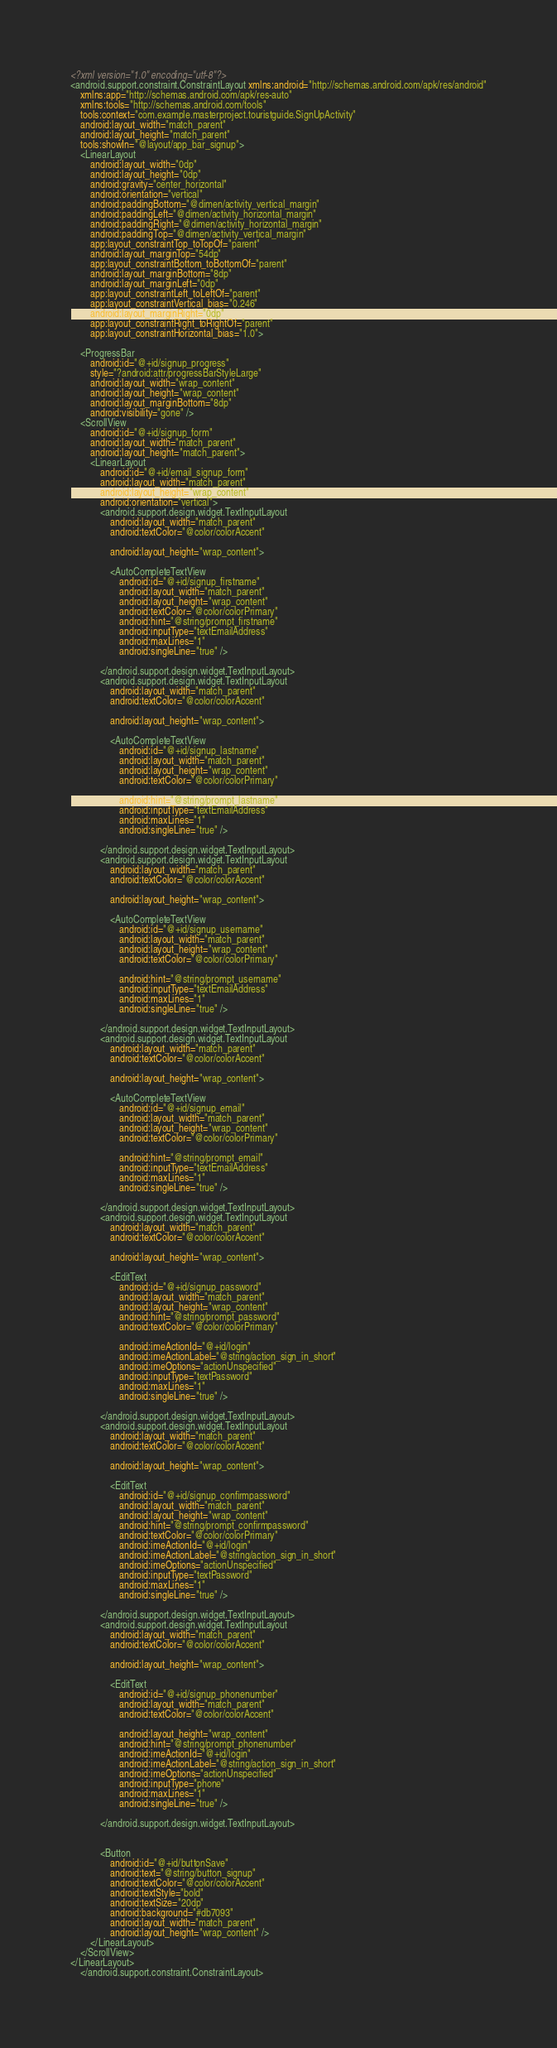<code> <loc_0><loc_0><loc_500><loc_500><_XML_><?xml version="1.0" encoding="utf-8"?>
<android.support.constraint.ConstraintLayout xmlns:android="http://schemas.android.com/apk/res/android"
    xmlns:app="http://schemas.android.com/apk/res-auto"
    xmlns:tools="http://schemas.android.com/tools"
    tools:context="com.example.masterproject.touristguide.SignUpActivity"
    android:layout_width="match_parent"
    android:layout_height="match_parent"
    tools:showIn="@layout/app_bar_signup">
    <LinearLayout
        android:layout_width="0dp"
        android:layout_height="0dp"
        android:gravity="center_horizontal"
        android:orientation="vertical"
        android:paddingBottom="@dimen/activity_vertical_margin"
        android:paddingLeft="@dimen/activity_horizontal_margin"
        android:paddingRight="@dimen/activity_horizontal_margin"
        android:paddingTop="@dimen/activity_vertical_margin"
        app:layout_constraintTop_toTopOf="parent"
        android:layout_marginTop="54dp"
        app:layout_constraintBottom_toBottomOf="parent"
        android:layout_marginBottom="8dp"
        android:layout_marginLeft="0dp"
        app:layout_constraintLeft_toLeftOf="parent"
        app:layout_constraintVertical_bias="0.246"
        android:layout_marginRight="0dp"
        app:layout_constraintRight_toRightOf="parent"
        app:layout_constraintHorizontal_bias="1.0">

    <ProgressBar
        android:id="@+id/signup_progress"
        style="?android:attr/progressBarStyleLarge"
        android:layout_width="wrap_content"
        android:layout_height="wrap_content"
        android:layout_marginBottom="8dp"
        android:visibility="gone" />
    <ScrollView
        android:id="@+id/signup_form"
        android:layout_width="match_parent"
        android:layout_height="match_parent">
        <LinearLayout
            android:id="@+id/email_signup_form"
            android:layout_width="match_parent"
            android:layout_height="wrap_content"
            android:orientation="vertical">
            <android.support.design.widget.TextInputLayout
                android:layout_width="match_parent"
                android:textColor="@color/colorAccent"

                android:layout_height="wrap_content">

                <AutoCompleteTextView
                    android:id="@+id/signup_firstname"
                    android:layout_width="match_parent"
                    android:layout_height="wrap_content"
                    android:textColor="@color/colorPrimary"
                    android:hint="@string/prompt_firstname"
                    android:inputType="textEmailAddress"
                    android:maxLines="1"
                    android:singleLine="true" />

            </android.support.design.widget.TextInputLayout>
            <android.support.design.widget.TextInputLayout
                android:layout_width="match_parent"
                android:textColor="@color/colorAccent"

                android:layout_height="wrap_content">

                <AutoCompleteTextView
                    android:id="@+id/signup_lastname"
                    android:layout_width="match_parent"
                    android:layout_height="wrap_content"
                    android:textColor="@color/colorPrimary"

                    android:hint="@string/prompt_lastname"
                    android:inputType="textEmailAddress"
                    android:maxLines="1"
                    android:singleLine="true" />

            </android.support.design.widget.TextInputLayout>
            <android.support.design.widget.TextInputLayout
                android:layout_width="match_parent"
                android:textColor="@color/colorAccent"

                android:layout_height="wrap_content">

                <AutoCompleteTextView
                    android:id="@+id/signup_username"
                    android:layout_width="match_parent"
                    android:layout_height="wrap_content"
                    android:textColor="@color/colorPrimary"

                    android:hint="@string/prompt_username"
                    android:inputType="textEmailAddress"
                    android:maxLines="1"
                    android:singleLine="true" />

            </android.support.design.widget.TextInputLayout>
            <android.support.design.widget.TextInputLayout
                android:layout_width="match_parent"
                android:textColor="@color/colorAccent"

                android:layout_height="wrap_content">

                <AutoCompleteTextView
                    android:id="@+id/signup_email"
                    android:layout_width="match_parent"
                    android:layout_height="wrap_content"
                    android:textColor="@color/colorPrimary"

                    android:hint="@string/prompt_email"
                    android:inputType="textEmailAddress"
                    android:maxLines="1"
                    android:singleLine="true" />

            </android.support.design.widget.TextInputLayout>
            <android.support.design.widget.TextInputLayout
                android:layout_width="match_parent"
                android:textColor="@color/colorAccent"

                android:layout_height="wrap_content">

                <EditText
                    android:id="@+id/signup_password"
                    android:layout_width="match_parent"
                    android:layout_height="wrap_content"
                    android:hint="@string/prompt_password"
                    android:textColor="@color/colorPrimary"

                    android:imeActionId="@+id/login"
                    android:imeActionLabel="@string/action_sign_in_short"
                    android:imeOptions="actionUnspecified"
                    android:inputType="textPassword"
                    android:maxLines="1"
                    android:singleLine="true" />

            </android.support.design.widget.TextInputLayout>
            <android.support.design.widget.TextInputLayout
                android:layout_width="match_parent"
                android:textColor="@color/colorAccent"

                android:layout_height="wrap_content">

                <EditText
                    android:id="@+id/signup_confirmpassword"
                    android:layout_width="match_parent"
                    android:layout_height="wrap_content"
                    android:hint="@string/prompt_confirmpassword"
                    android:textColor="@color/colorPrimary"
                    android:imeActionId="@+id/login"
                    android:imeActionLabel="@string/action_sign_in_short"
                    android:imeOptions="actionUnspecified"
                    android:inputType="textPassword"
                    android:maxLines="1"
                    android:singleLine="true" />

            </android.support.design.widget.TextInputLayout>
            <android.support.design.widget.TextInputLayout
                android:layout_width="match_parent"
                android:textColor="@color/colorAccent"

                android:layout_height="wrap_content">

                <EditText
                    android:id="@+id/signup_phonenumber"
                    android:layout_width="match_parent"
                    android:textColor="@color/colorAccent"

                    android:layout_height="wrap_content"
                    android:hint="@string/prompt_phonenumber"
                    android:imeActionId="@+id/login"
                    android:imeActionLabel="@string/action_sign_in_short"
                    android:imeOptions="actionUnspecified"
                    android:inputType="phone"
                    android:maxLines="1"
                    android:singleLine="true" />

            </android.support.design.widget.TextInputLayout>


            <Button
                android:id="@+id/buttonSave"
                android:text="@string/button_signup"
                android:textColor="@color/colorAccent"
                android:textStyle="bold"
                android:textSize="20dp"
                android:background="#db7093"
                android:layout_width="match_parent"
                android:layout_height="wrap_content" />
        </LinearLayout>
    </ScrollView>
</LinearLayout>
    </android.support.constraint.ConstraintLayout></code> 